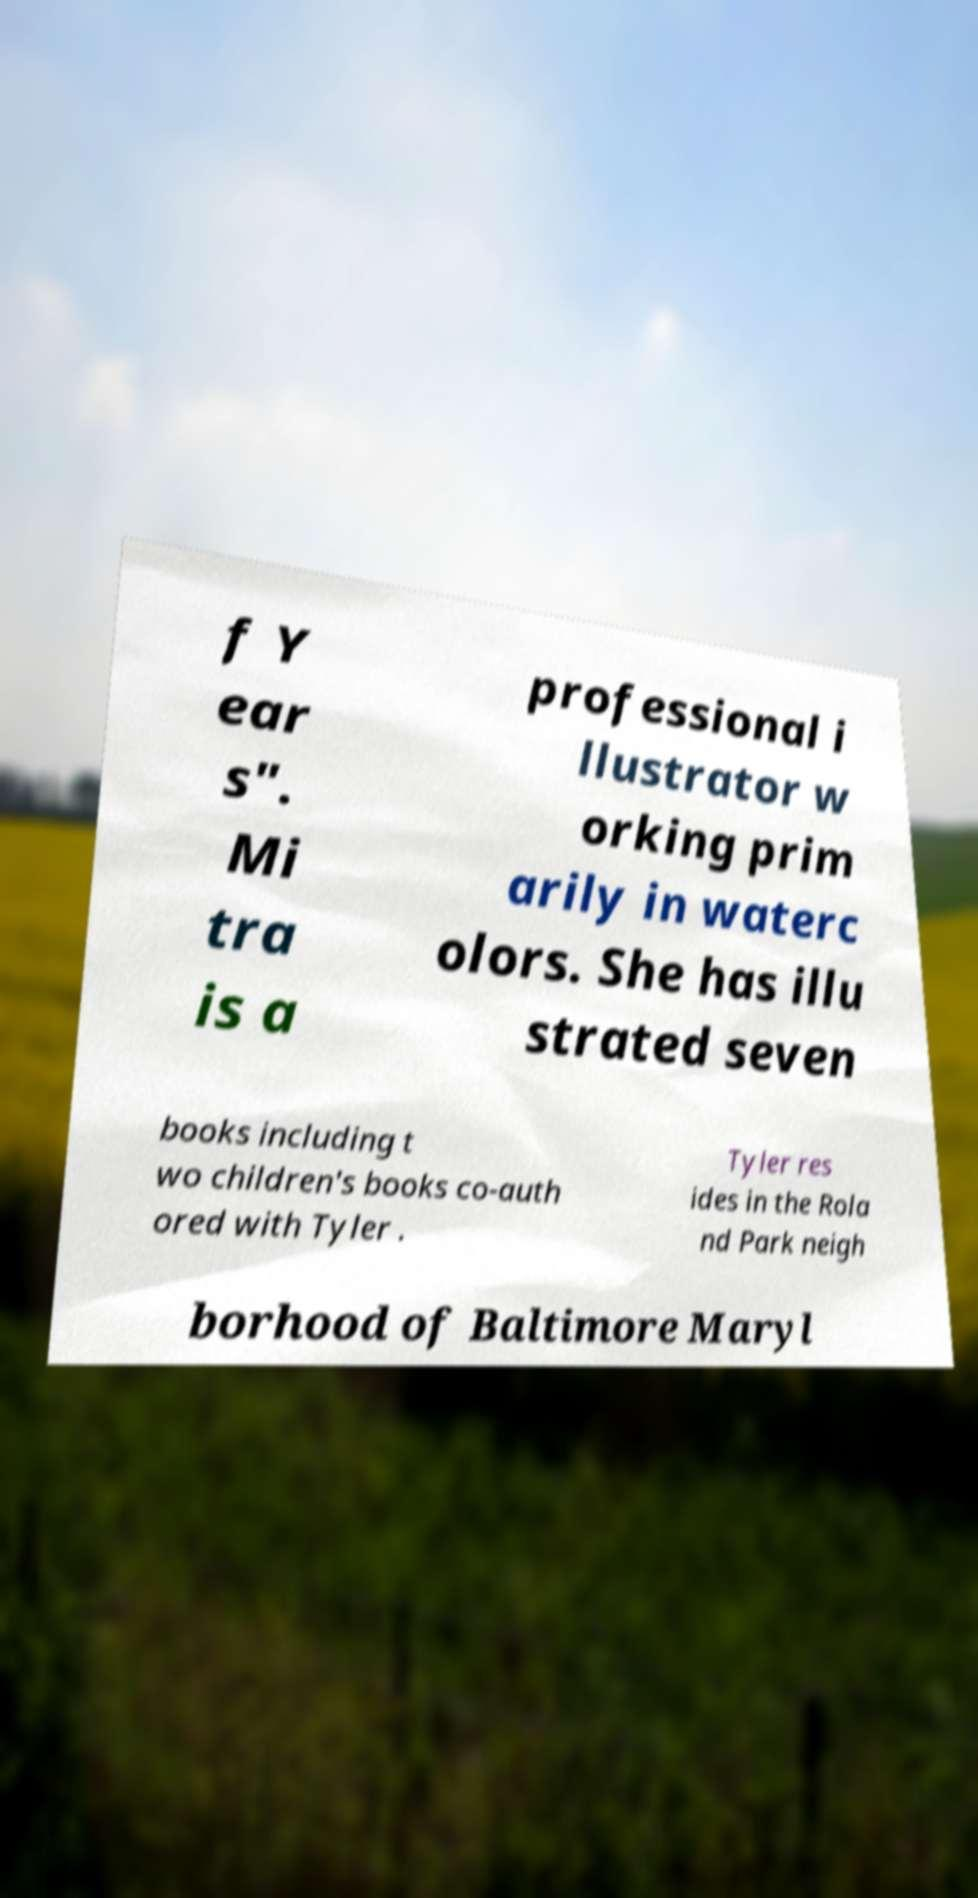There's text embedded in this image that I need extracted. Can you transcribe it verbatim? f Y ear s". Mi tra is a professional i llustrator w orking prim arily in waterc olors. She has illu strated seven books including t wo children's books co-auth ored with Tyler . Tyler res ides in the Rola nd Park neigh borhood of Baltimore Maryl 